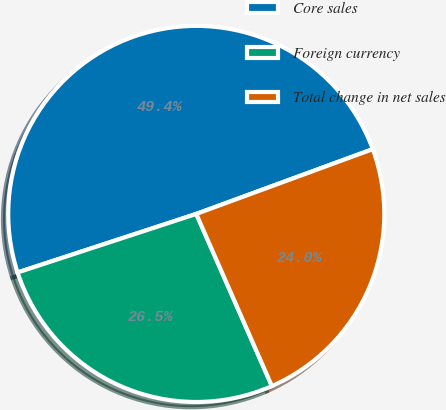Convert chart to OTSL. <chart><loc_0><loc_0><loc_500><loc_500><pie_chart><fcel>Core sales<fcel>Foreign currency<fcel>Total change in net sales<nl><fcel>49.44%<fcel>26.55%<fcel>24.01%<nl></chart> 